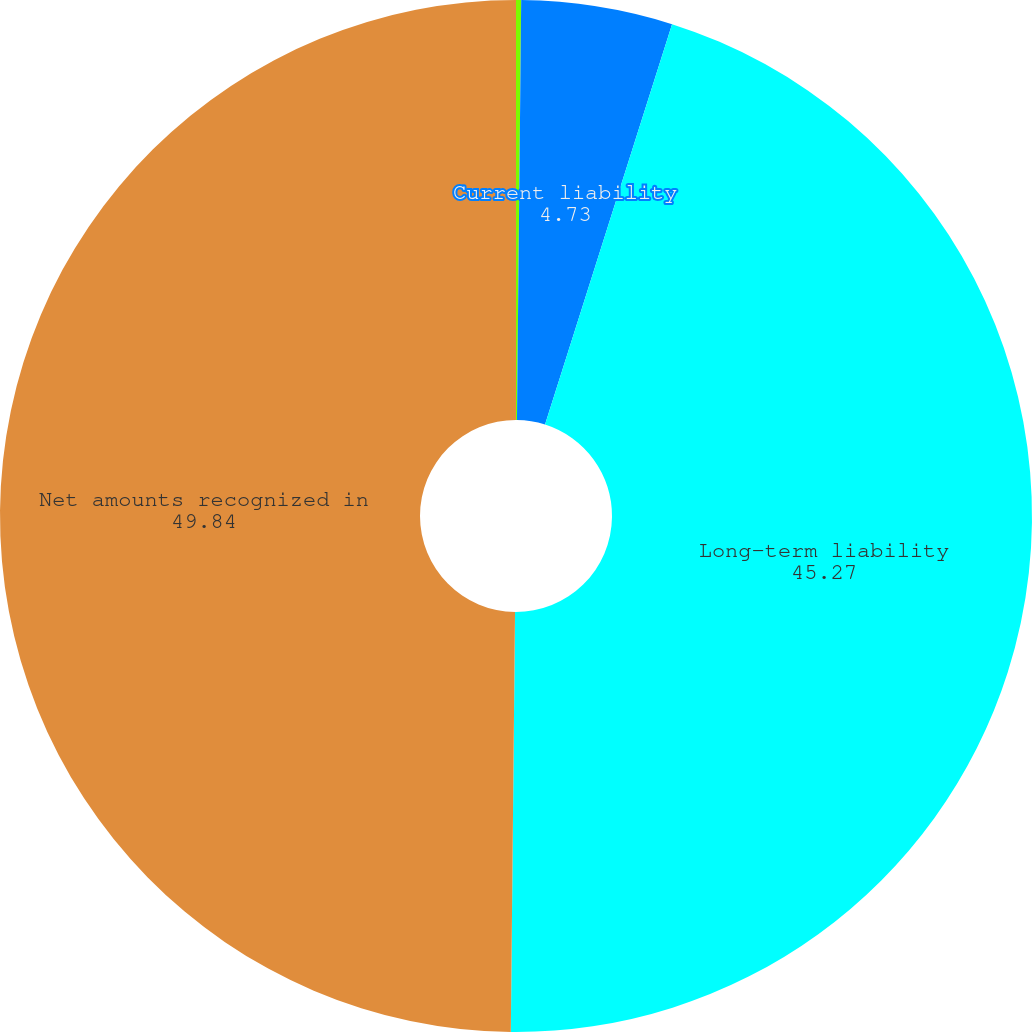Convert chart. <chart><loc_0><loc_0><loc_500><loc_500><pie_chart><fcel>Noncurrent asset<fcel>Current liability<fcel>Long-term liability<fcel>Net amounts recognized in<nl><fcel>0.16%<fcel>4.73%<fcel>45.27%<fcel>49.84%<nl></chart> 